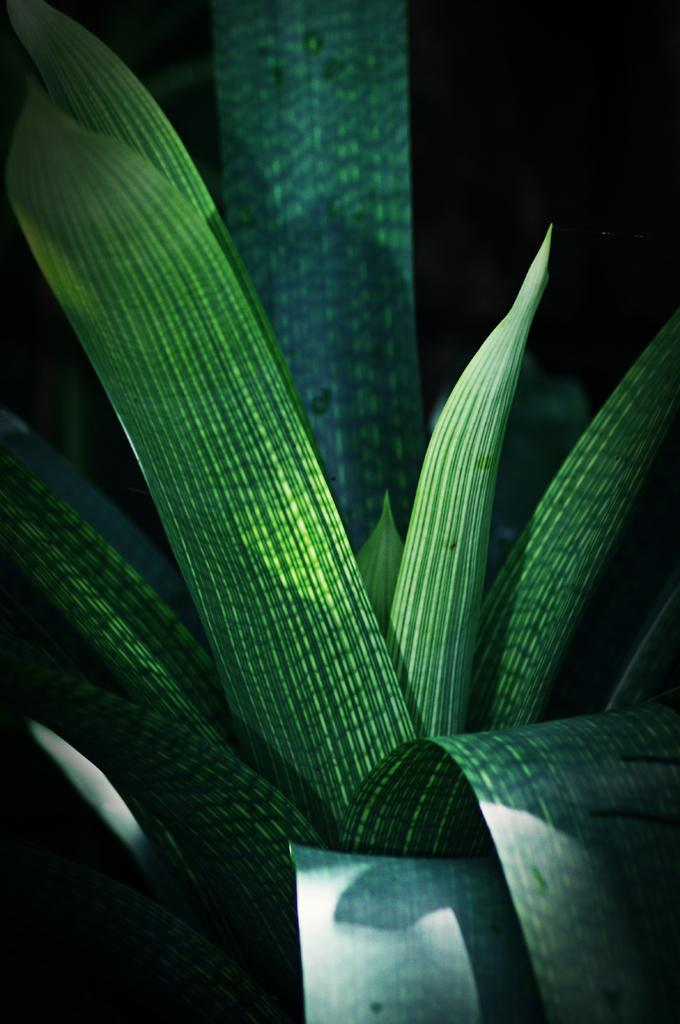What is the main subject in the image? There is a plant in the image. What color is the background of the image? The background of the image is black. What type of disease is affecting the plant in the image? There is no indication of any disease affecting the plant in the image. Is there a tent visible in the image? There is no tent present in the image. 